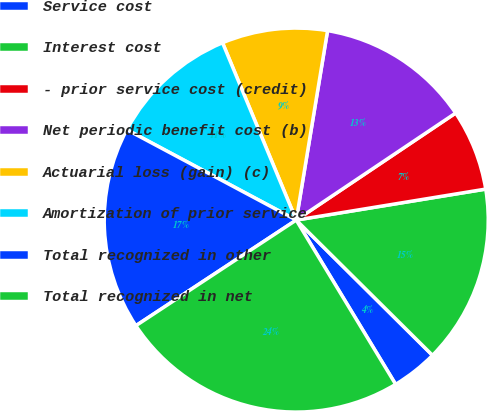<chart> <loc_0><loc_0><loc_500><loc_500><pie_chart><fcel>Service cost<fcel>Interest cost<fcel>- prior service cost (credit)<fcel>Net periodic benefit cost (b)<fcel>Actuarial loss (gain) (c)<fcel>Amortization of prior service<fcel>Total recognized in other<fcel>Total recognized in net<nl><fcel>3.9%<fcel>15.02%<fcel>6.83%<fcel>12.98%<fcel>8.88%<fcel>10.93%<fcel>17.07%<fcel>24.39%<nl></chart> 